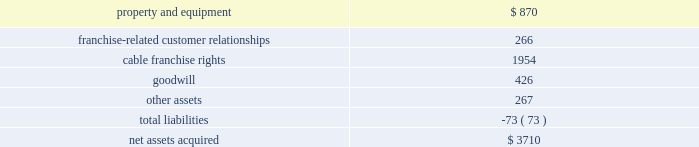Other .
The aggregate purchase price of these other 2008 acquis- itions was approximately $ 610 million .
None of these acquisitions were material to our consolidated financial statements for the year ended december 31 , 2008 .
2007 acquisitions the houston transaction in july 2006 , we initiated the dissolution of texas and kansas city cable partners ( the 201chouston transaction 201d ) , our 50%-50% ( 50%-50 % ) cable system partnership with time warner cable .
On january 1 , 2007 , the distribution of assets by texas and kansas city cable partners was completed and we received the cable system serving hous- ton , texas ( the 201chouston asset pool 201d ) and time warner cable received the cable systems serving kansas city , south and west texas , and new mexico ( the 201ckansas city asset pool 201d ) .
We accounted for the distribution of assets by texas and kansas city cable partners as a sale of our 50% ( 50 % ) interest in the kansas city asset pool in exchange for acquiring an additional 50% ( 50 % ) interest in the houston asset pool .
This transaction resulted in an increase of approximately 700000 video customers .
The estimated fair value of the 50% ( 50 % ) interest of the houston asset pool we received was approximately $ 1.1 billion and resulted in a pretax gain of approx- imately $ 500 million , which is included in other income ( expense ) .
We recorded our 50% ( 50 % ) interest in the houston asset pool as a step acquisition in accordance with sfas no .
141 .
The results of operations for the cable systems acquired in the houston transaction have been reported in our cable segment since august 1 , 2006 and in our consolidated financial statements since january 1 , 2007 ( the date of the distribution of assets ) .
The weighted-average amortization period of the franchise-related customer relationship intangible assets acquired was 7 years .
As a result of the houston transaction , we reversed deferred tax liabilities of approximately $ 200 million , which were primarily related to the excess of tax basis of the assets acquired over the tax basis of the assets exchanged , and reduced the amount of goodwill that would have otherwise been recorded in the acquis- ition .
Substantially all of the goodwill recorded is expected to be amortizable for tax purposes .
The table below presents the purchase price allocation to assets acquired and liabilities assumed as a result of the houston transaction .
( in millions ) .
Other 2007 acquisitions in april 2007 , we acquired fandango , an online entertainment site and movie-ticket service .
The results of operations of fandango have been included in our consolidated financial statements since the acquisition date and are reported in corporate and other .
In june 2007 , we acquired rainbow media holdings llc 2019s 60% ( 60 % ) interest in comcast sportsnet bay area ( formerly known as bay area sportsnet ) and its 50% ( 50 % ) interest in comcast sportsnet new england ( formerly known as sports channel new england ) , expanding our regional sports networks .
The completion of this transaction resulted in our 100% ( 100 % ) ownership in comcast sportsnet new england and 60% ( 60 % ) ownership in comcast sportsnet bay area .
In august 2007 , we acquired the cable system of patriot media serving approximately 81000 video customers in central new jersey .
The results of operations of patriot media , comcast sportsnet bay area and comcast sportsnet new england have been included in our consolidated financial statements since their acquisition dates and are reported in our cable segment .
The aggregate purchase price of these other 2007 acquisitions was approximately $ 1.288 billion .
None of these acquisitions were material to our consolidated financial statements for the year ended december 31 , 2007 .
2006 acquisitions the adelphia and time warner transactions in april 2005 , we entered into an agreement with adelphia communications ( 201cadelphia 201d ) in which we agreed to acquire cer- tain assets and assume certain liabilities of adelphia ( the 201cadelphia acquisition 201d ) .
At the same time , we and time warner cable inc .
And certain of its affiliates ( 201ctwc 201d ) entered into several agreements in which we agreed to ( i ) have our interest in time warner entertainment company , l.p .
( 201ctwe 201d ) redeemed , ( ii ) have our interest in twc redeemed ( together with the twe redemption , the 201credemptions 201d ) and ( iii ) exchange certain cable systems acquired from adelphia and certain comcast cable systems with twc ( the 201cexchanges 201d ) .
On july 31 , 2006 , these transactions were com- pleted .
We collectively refer to the adelphia acquisition , the redemptions and the exchanges as the 201cadelphia and time warner transactions . 201d also in april 2005 , adelphia and twc entered into an agreement for the acquisition of substantially all of the remaining cable system assets and the assumption of certain of the liabilities of adelphia .
The adelphia and time warner transactions resulted in a net increase of 1.7 million video customers , a net cash payment by us of approximately $ 1.5 billion and the disposition of our ownership interests in twe and twc and the assets of two cable system partnerships .
Comcast 2008 annual report on form 10-k 52 .
What was the value of the assets acquired before adjustment for the liabilities in millions? 
Computations: (3710 + 73)
Answer: 3783.0. 